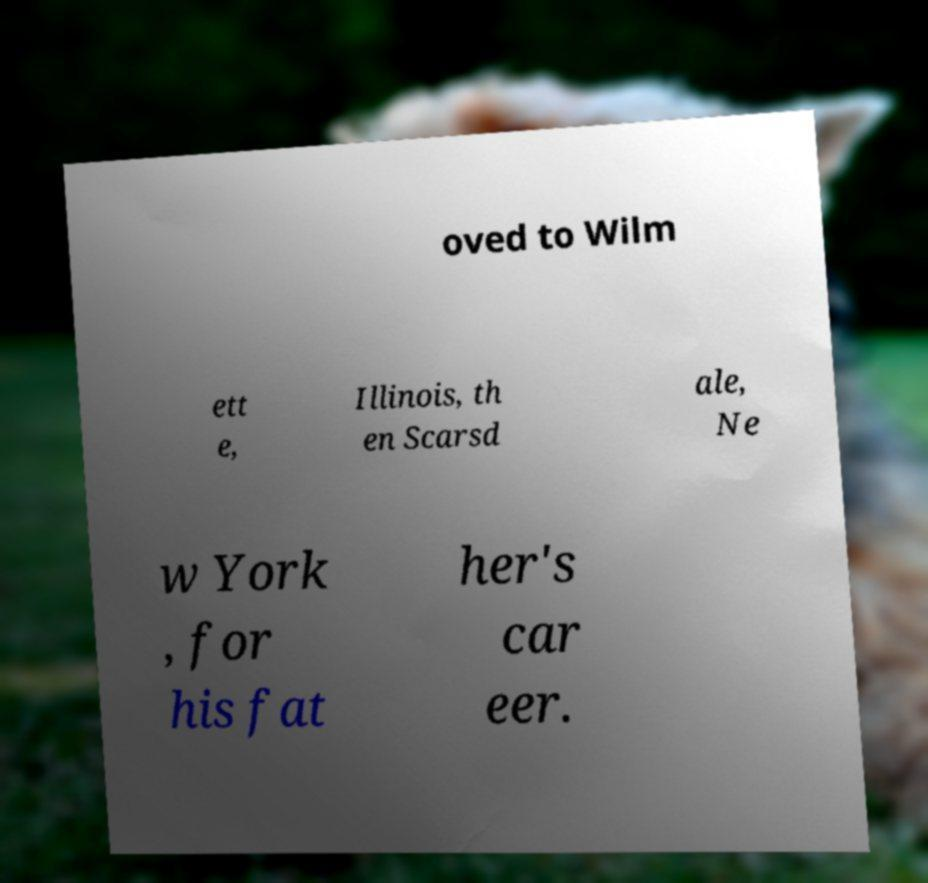For documentation purposes, I need the text within this image transcribed. Could you provide that? oved to Wilm ett e, Illinois, th en Scarsd ale, Ne w York , for his fat her's car eer. 